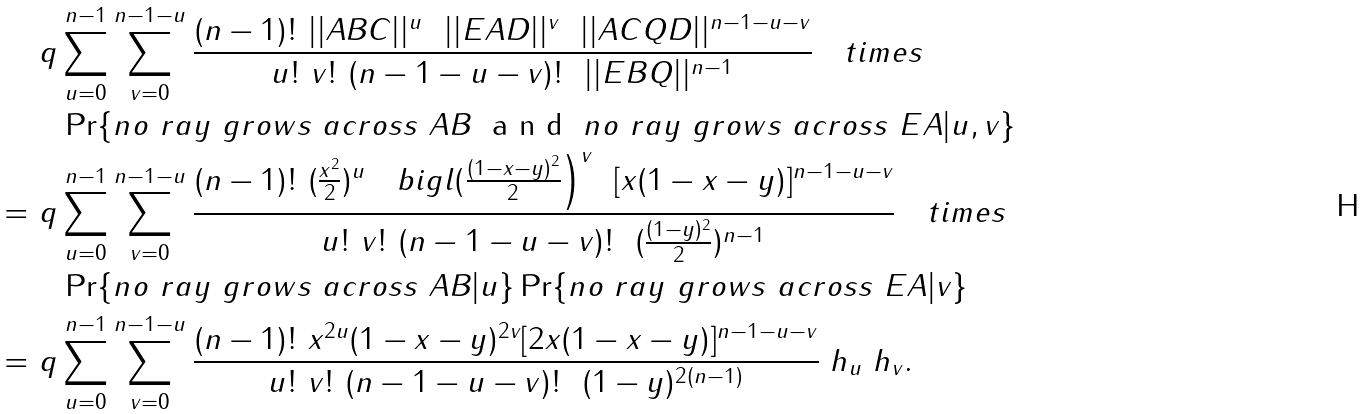<formula> <loc_0><loc_0><loc_500><loc_500>& \ q \sum _ { u = 0 } ^ { n - 1 } \sum _ { v = 0 } ^ { n - 1 - u } \frac { ( n - 1 ) ! \ | | A B C | | ^ { u } \ \ | | E A D | | ^ { v } \ \ | | A C Q D | | ^ { n - 1 - u - v } } { u ! \ v ! \ ( n - 1 - u - v ) ! \ \ | | E B Q | | ^ { n - 1 } } \quad t i m e s \\ & \quad \Pr \{ n o \ r a y \ g r o w s \ a c r o s s \ A B \ \emph { a n d } \ n o \ r a y \ g r o w s \ a c r o s s \ E A | u , v \} \\ = & \ q \sum _ { u = 0 } ^ { n - 1 } \sum _ { v = 0 } ^ { n - 1 - u } \frac { ( n - 1 ) ! \ ( \frac { x ^ { 2 } } { 2 } ) ^ { u } \quad b i g l ( \frac { ( 1 - x - y ) ^ { 2 } } { 2 } \Big ) ^ { v } \ \ [ x ( 1 - x - y ) ] ^ { n - 1 - u - v } } { u ! \ v ! \ ( n - 1 - u - v ) ! \ \ ( \frac { ( 1 - y ) ^ { 2 } } { 2 } ) ^ { n - 1 } } \quad t i m e s \\ & \quad \Pr \{ n o \ r a y \ g r o w s \ a c r o s s \ A B | u \} \Pr \{ n o \ r a y \ g r o w s \ a c r o s s \ E A | v \} \\ = & \ q \sum _ { u = 0 } ^ { n - 1 } \sum _ { v = 0 } ^ { n - 1 - u } \frac { ( n - 1 ) ! \ x ^ { 2 u } ( 1 - x - y ) ^ { 2 v } [ 2 x ( 1 - x - y ) ] ^ { n - 1 - u - v } } { u ! \ v ! \ ( n - 1 - u - v ) ! \ \ ( 1 - y ) ^ { 2 ( n - 1 ) } } \ h _ { u } \ h _ { v } .</formula> 